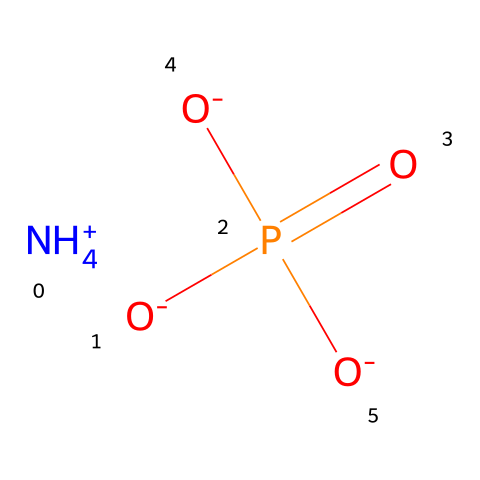What is the total number of phosphorus atoms in this chemical? The chemical structure contains one phosphorus atom, which is indicated in the formula as part of the phosphate group.
Answer: one How many oxygen atoms are present in this molecule? The formula shows a phosphorus atom bonded to four oxygen atoms, which are clearly indicated.
Answer: four What is the charge of the ammonium ion in this structure? The ammonium ion is represented by [NH4+], which indicates it has a positive charge.
Answer: positive What functional group is present in this chemical? The presence of the phosphate group (P(=O)([O-])[O-]) indicates the existence of a phosphonate, which is a typical functional group in fire retardants.
Answer: phosphonate Which part of the chemical indicates its fire-retardant properties? The presence of the phosphate group contributes to its fire-retardant capacity by forming a protective layer when exposed to high temperatures, inhibiting combustion.
Answer: phosphate group Is this molecule soluble in water? The presence of ionic entities like ammonium and negatively charged oxygen atoms suggests that the molecule is hydrophilic, which typically indicates good water solubility.
Answer: yes How many total charges does this molecule have? The ammonium ion has a charge of +1 and the three oxygen atoms carry a charge of -1 each, leading to a total charge of -2 overall.
Answer: negative two 